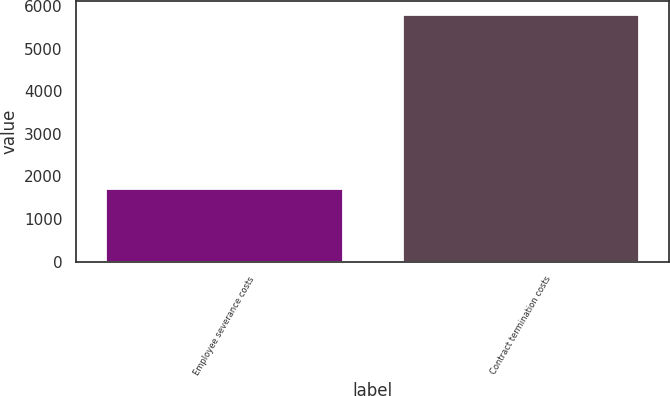<chart> <loc_0><loc_0><loc_500><loc_500><bar_chart><fcel>Employee severance costs<fcel>Contract termination costs<nl><fcel>1737<fcel>5821<nl></chart> 